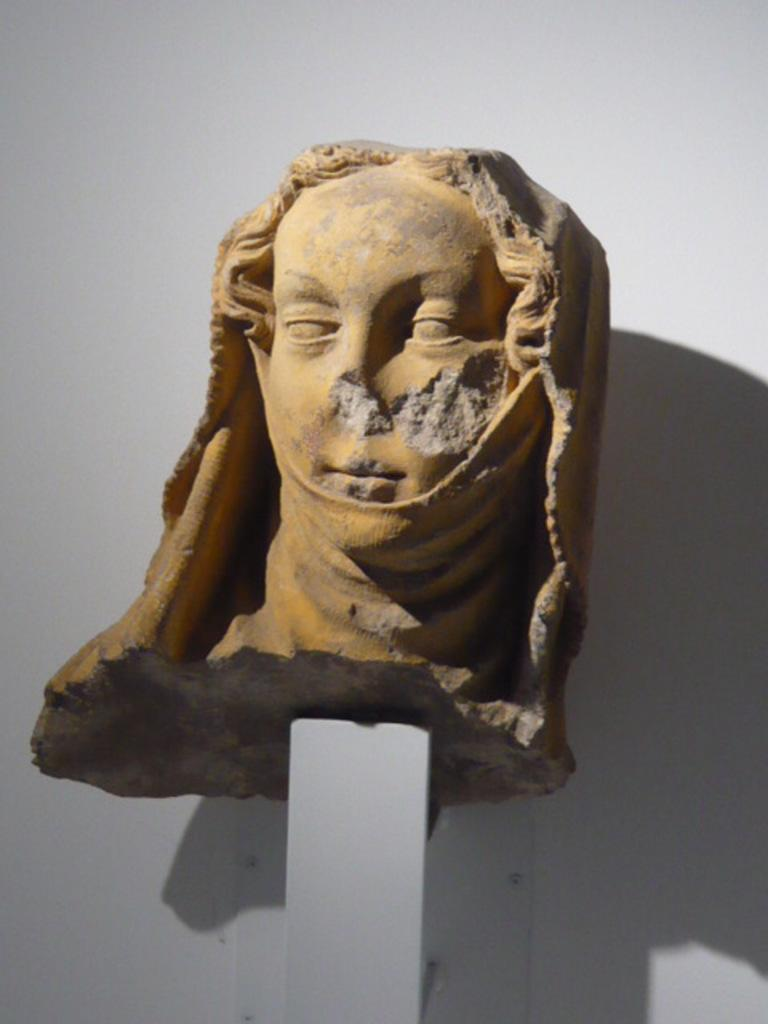What is on the pillar in the image? There is a sculpture on a pillar in the image. What does the sculpture depict? The sculpture depicts a person's face. Is the sculpture in perfect condition? No, the sculpture is slightly broken. What is behind the sculpture? There is a wall behind the sculpture. What color is the pocket on the person's face in the image? There is no pocket present on the person's face in the image, as the sculpture depicts a face without any clothing or accessories. 